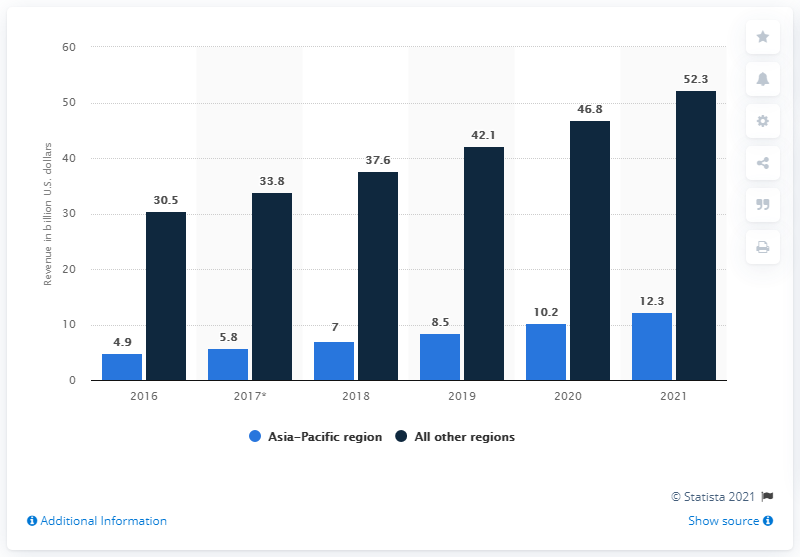Identify some key points in this picture. The projected revenue for the given year is 52.3 million dollars. In 2018, the values of two bars were different by 30.6... The statistic provides projections for the annual revenue of pharmaceutical contract research organizations in 2021. 